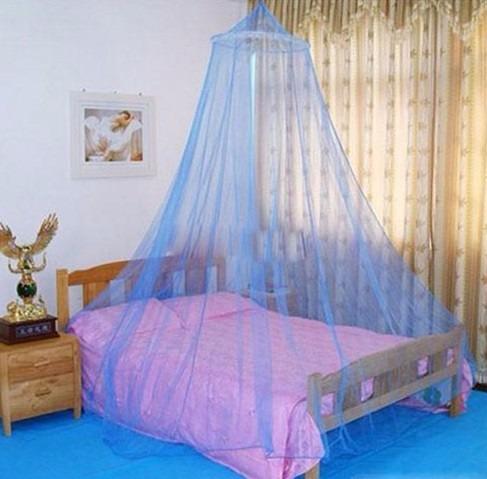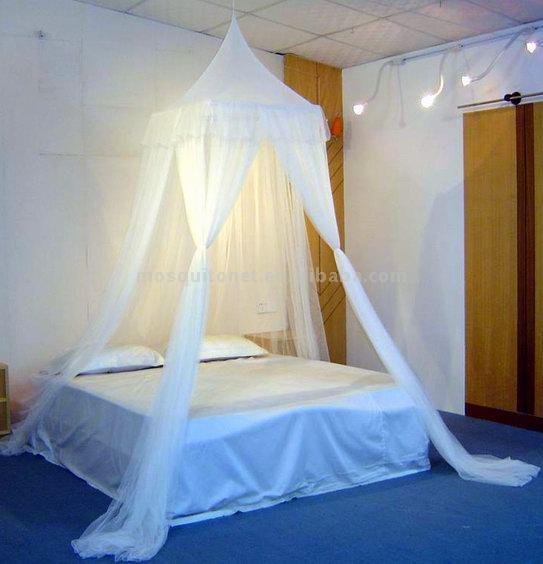The first image is the image on the left, the second image is the image on the right. For the images shown, is this caption "One of the walls has at least one rectangular picture hanging from it." true? Answer yes or no. Yes. The first image is the image on the left, the second image is the image on the right. Given the left and right images, does the statement "At least one image shows a bed with a wooden headboard." hold true? Answer yes or no. Yes. 